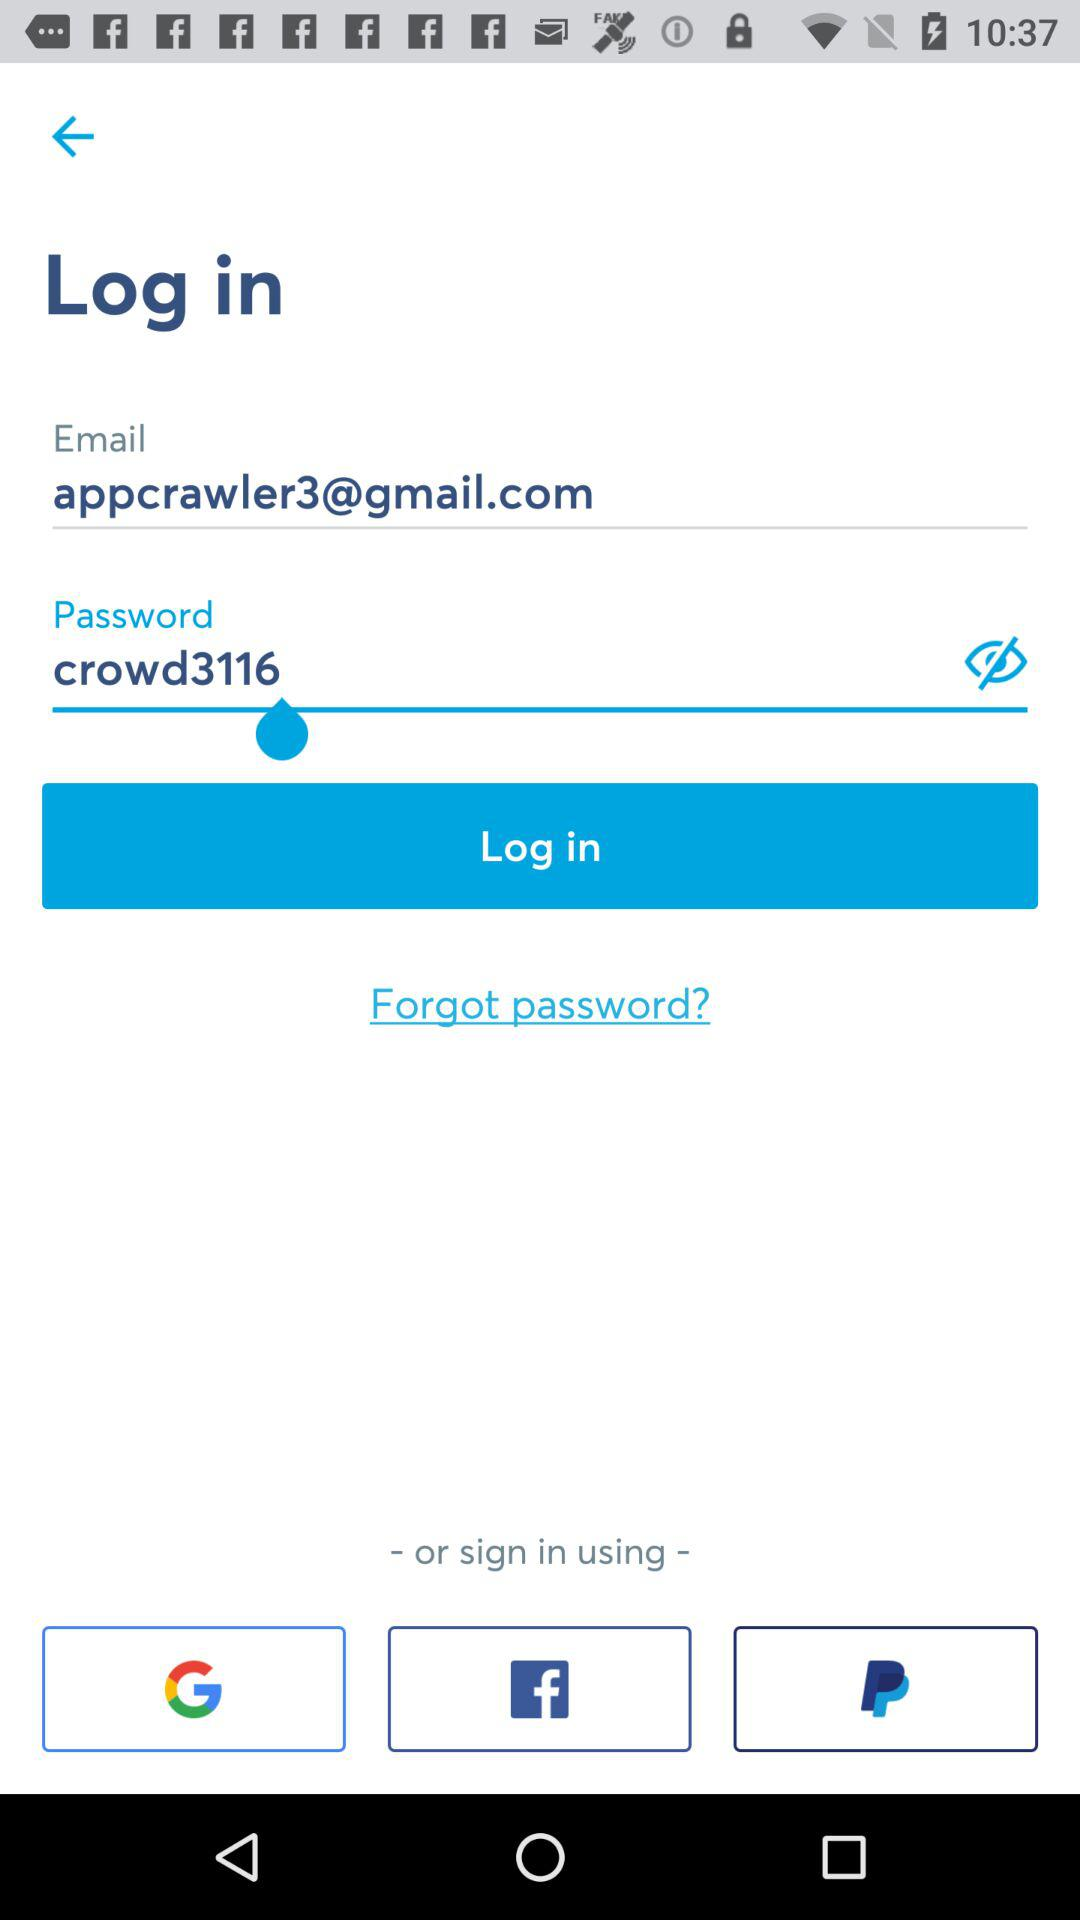What are the different options available for logging in? The different options available for logging in are "Email", "Google", "Facebook" and "PayPal". 